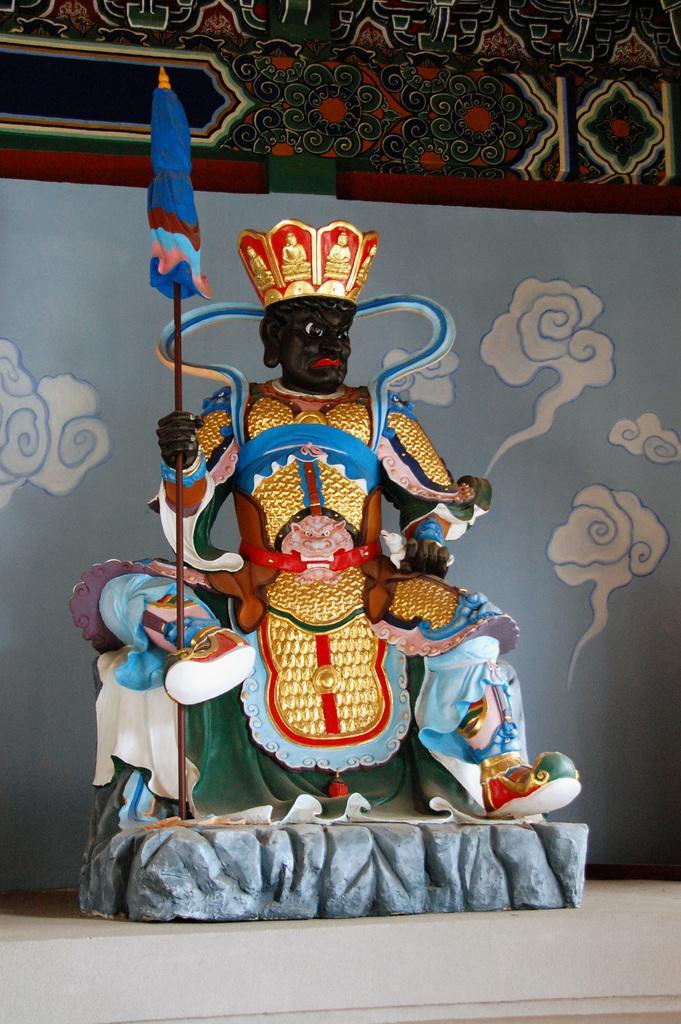In one or two sentences, can you explain what this image depicts? Here in this picture, in the middle we can see a statue present over a place and behind that we can see a curtain present. 